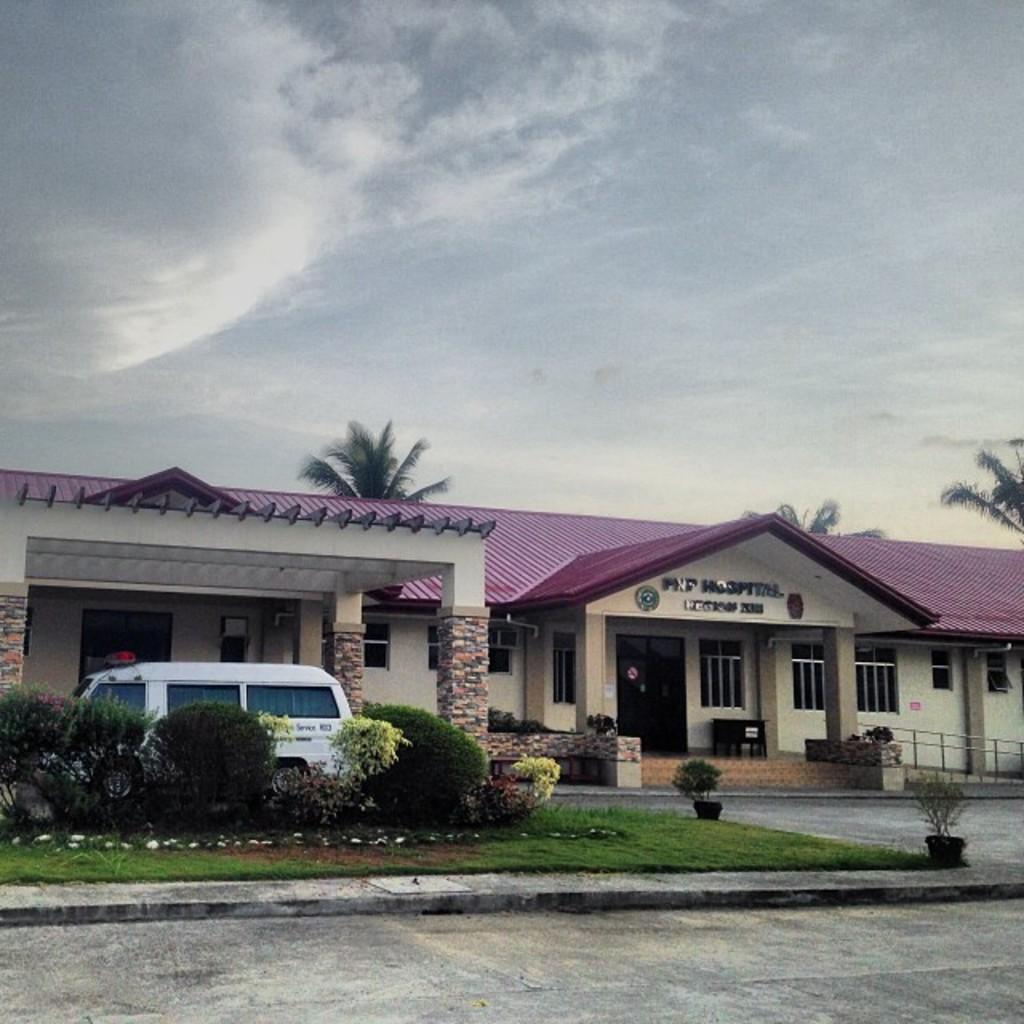How would you summarize this image in a sentence or two? In the middle of a picture we can see trees, building, planter, vehicle, grass, flower pot, text, railing and other objects. At the bottom we can see road. At the top there is sky. 